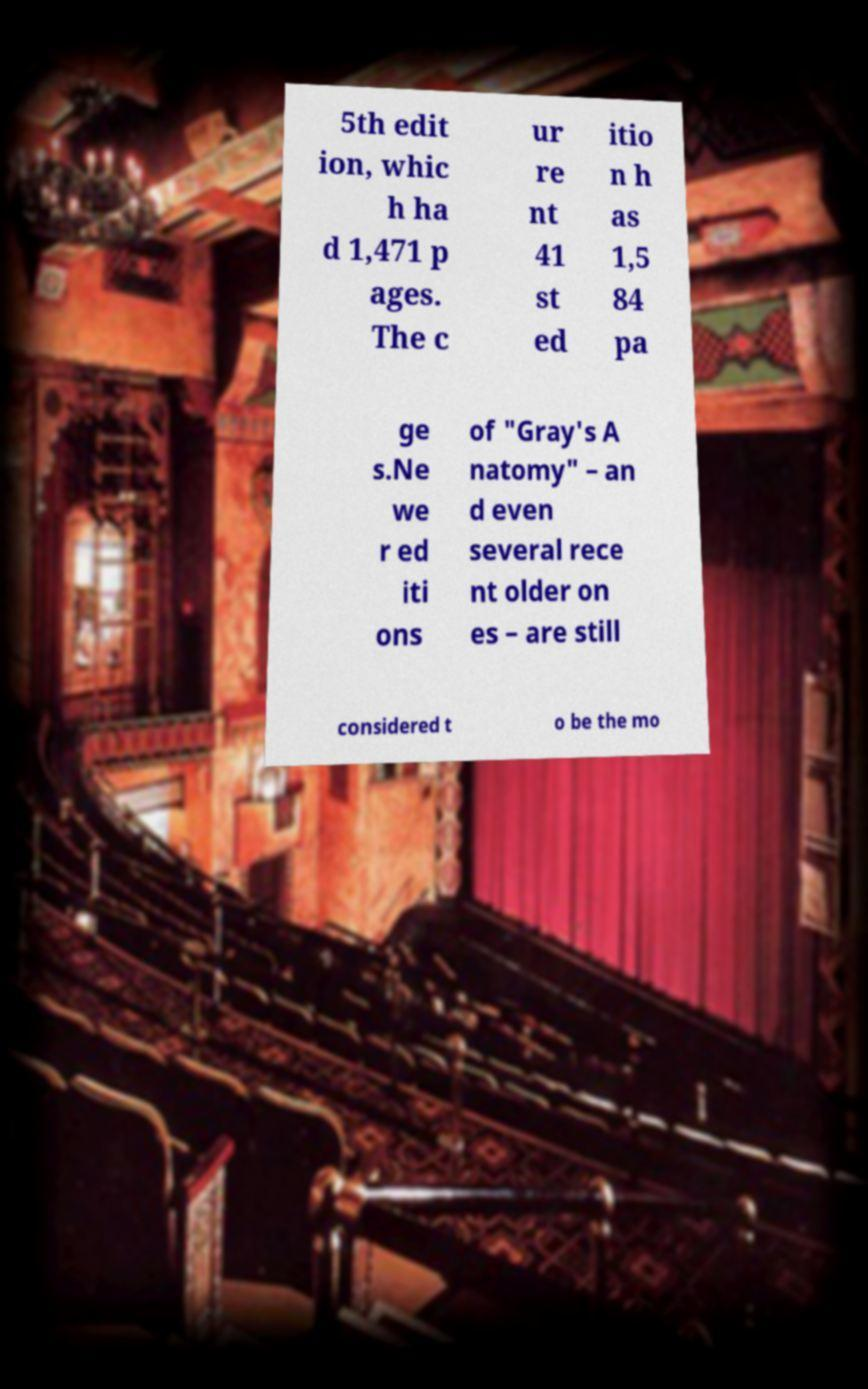Could you extract and type out the text from this image? 5th edit ion, whic h ha d 1,471 p ages. The c ur re nt 41 st ed itio n h as 1,5 84 pa ge s.Ne we r ed iti ons of "Gray's A natomy" – an d even several rece nt older on es – are still considered t o be the mo 